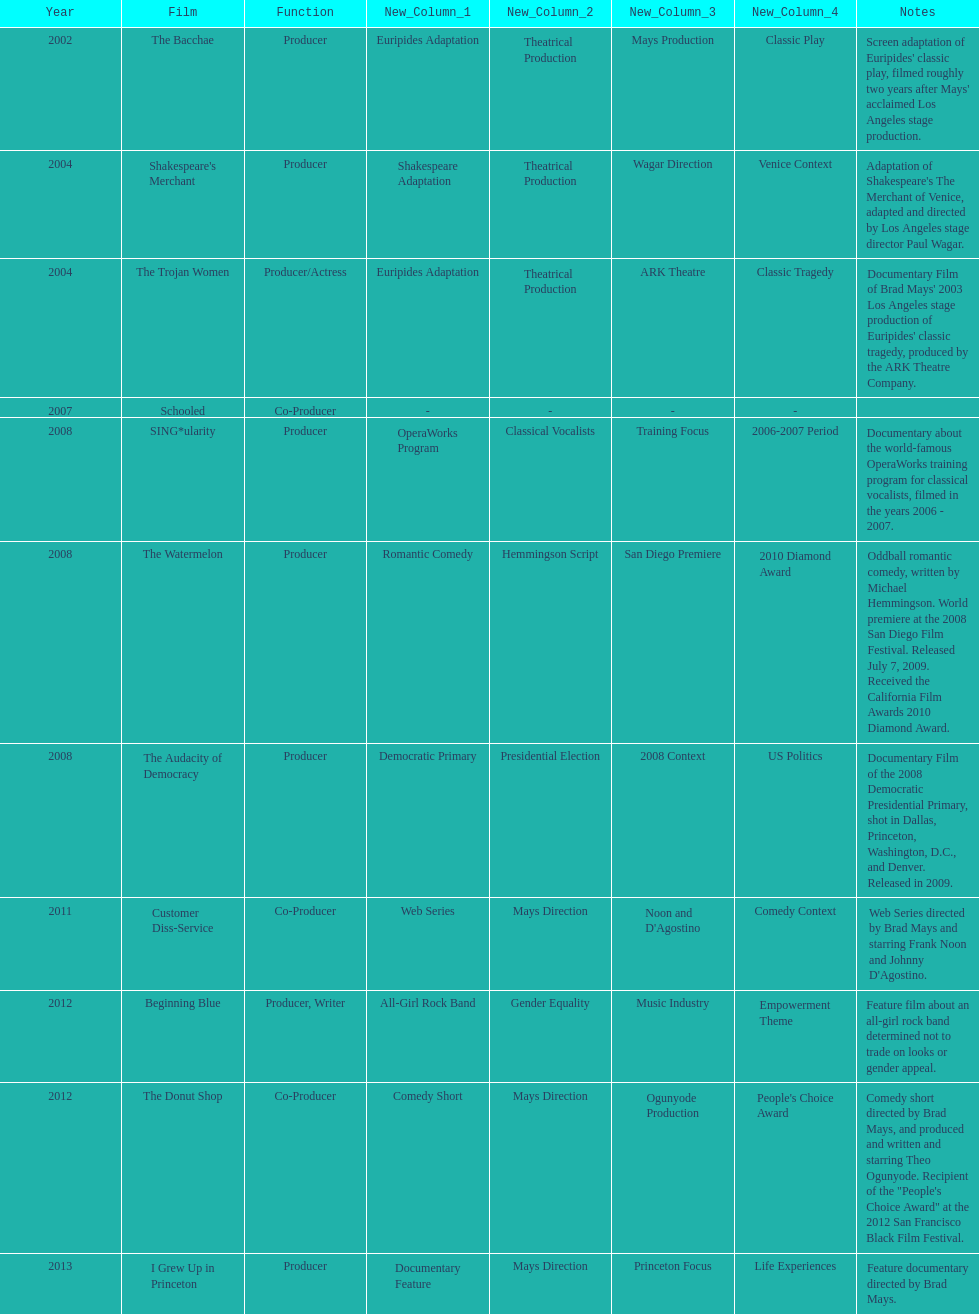What documentary film was produced before the year 2011 but after 2008? The Audacity of Democracy. 